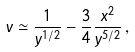<formula> <loc_0><loc_0><loc_500><loc_500>v \simeq \frac { 1 } { y ^ { 1 / 2 } } - \frac { 3 } { 4 } \frac { x ^ { 2 } } { y ^ { 5 / 2 } } \, ,</formula> 